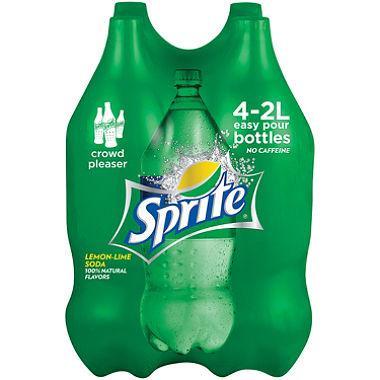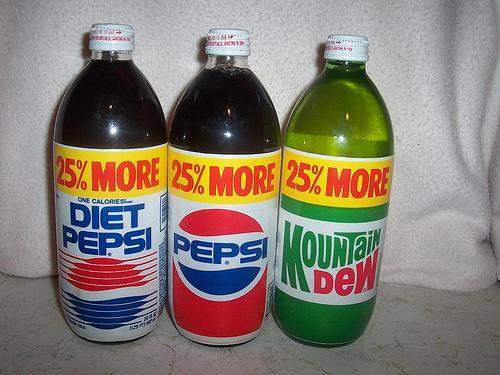The first image is the image on the left, the second image is the image on the right. Assess this claim about the two images: "There are two bottles total.". Correct or not? Answer yes or no. No. The first image is the image on the left, the second image is the image on the right. Examine the images to the left and right. Is the description "All of the soda bottles are green." accurate? Answer yes or no. No. 